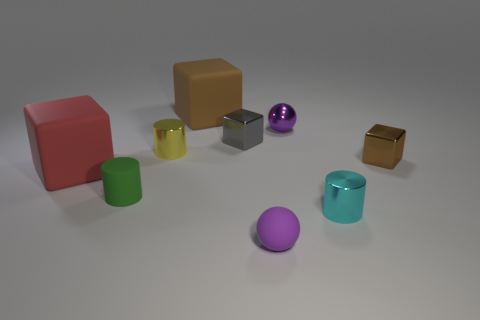Is there a small yellow metallic object of the same shape as the red object? no 